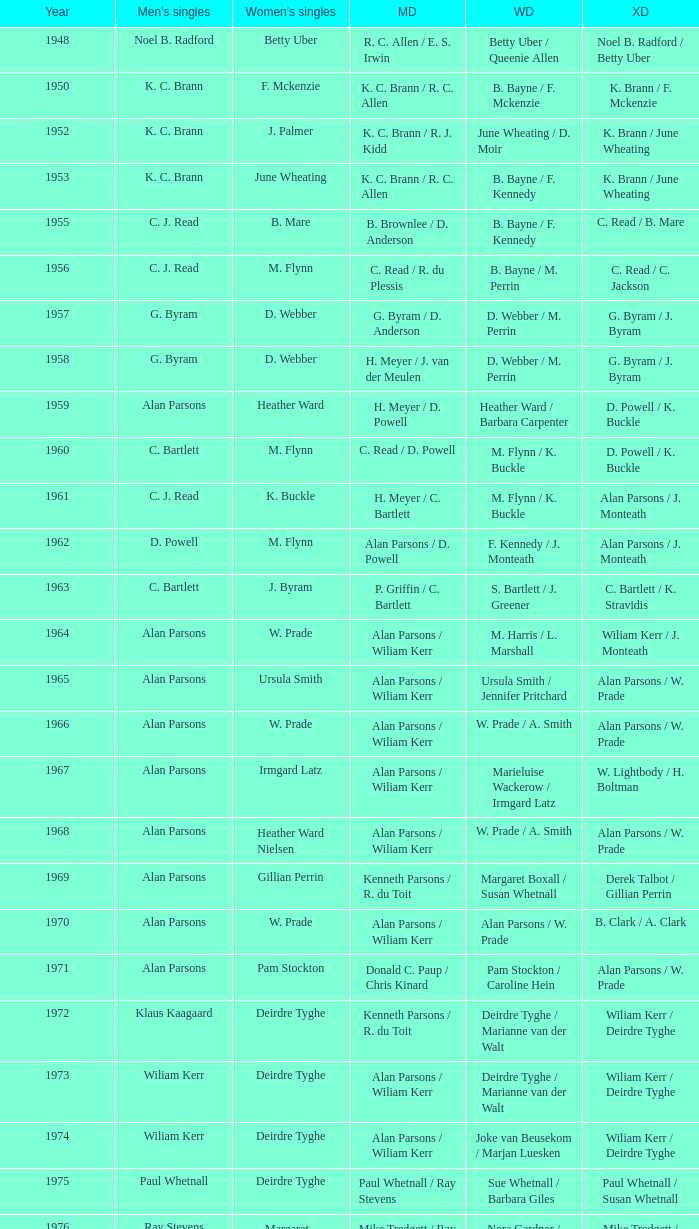Could you help me parse every detail presented in this table? {'header': ['Year', "Men's singles", "Women's singles", 'MD', 'WD', 'XD'], 'rows': [['1948', 'Noel B. Radford', 'Betty Uber', 'R. C. Allen / E. S. Irwin', 'Betty Uber / Queenie Allen', 'Noel B. Radford / Betty Uber'], ['1950', 'K. C. Brann', 'F. Mckenzie', 'K. C. Brann / R. C. Allen', 'B. Bayne / F. Mckenzie', 'K. Brann / F. Mckenzie'], ['1952', 'K. C. Brann', 'J. Palmer', 'K. C. Brann / R. J. Kidd', 'June Wheating / D. Moir', 'K. Brann / June Wheating'], ['1953', 'K. C. Brann', 'June Wheating', 'K. C. Brann / R. C. Allen', 'B. Bayne / F. Kennedy', 'K. Brann / June Wheating'], ['1955', 'C. J. Read', 'B. Mare', 'B. Brownlee / D. Anderson', 'B. Bayne / F. Kennedy', 'C. Read / B. Mare'], ['1956', 'C. J. Read', 'M. Flynn', 'C. Read / R. du Plessis', 'B. Bayne / M. Perrin', 'C. Read / C. Jackson'], ['1957', 'G. Byram', 'D. Webber', 'G. Byram / D. Anderson', 'D. Webber / M. Perrin', 'G. Byram / J. Byram'], ['1958', 'G. Byram', 'D. Webber', 'H. Meyer / J. van der Meulen', 'D. Webber / M. Perrin', 'G. Byram / J. Byram'], ['1959', 'Alan Parsons', 'Heather Ward', 'H. Meyer / D. Powell', 'Heather Ward / Barbara Carpenter', 'D. Powell / K. Buckle'], ['1960', 'C. Bartlett', 'M. Flynn', 'C. Read / D. Powell', 'M. Flynn / K. Buckle', 'D. Powell / K. Buckle'], ['1961', 'C. J. Read', 'K. Buckle', 'H. Meyer / C. Bartlett', 'M. Flynn / K. Buckle', 'Alan Parsons / J. Monteath'], ['1962', 'D. Powell', 'M. Flynn', 'Alan Parsons / D. Powell', 'F. Kennedy / J. Monteath', 'Alan Parsons / J. Monteath'], ['1963', 'C. Bartlett', 'J. Byram', 'P. Griffin / C. Bartlett', 'S. Bartlett / J. Greener', 'C. Bartlett / K. Stravidis'], ['1964', 'Alan Parsons', 'W. Prade', 'Alan Parsons / Wiliam Kerr', 'M. Harris / L. Marshall', 'Wiliam Kerr / J. Monteath'], ['1965', 'Alan Parsons', 'Ursula Smith', 'Alan Parsons / Wiliam Kerr', 'Ursula Smith / Jennifer Pritchard', 'Alan Parsons / W. Prade'], ['1966', 'Alan Parsons', 'W. Prade', 'Alan Parsons / Wiliam Kerr', 'W. Prade / A. Smith', 'Alan Parsons / W. Prade'], ['1967', 'Alan Parsons', 'Irmgard Latz', 'Alan Parsons / Wiliam Kerr', 'Marieluise Wackerow / Irmgard Latz', 'W. Lightbody / H. Boltman'], ['1968', 'Alan Parsons', 'Heather Ward Nielsen', 'Alan Parsons / Wiliam Kerr', 'W. Prade / A. Smith', 'Alan Parsons / W. Prade'], ['1969', 'Alan Parsons', 'Gillian Perrin', 'Kenneth Parsons / R. du Toit', 'Margaret Boxall / Susan Whetnall', 'Derek Talbot / Gillian Perrin'], ['1970', 'Alan Parsons', 'W. Prade', 'Alan Parsons / Wiliam Kerr', 'Alan Parsons / W. Prade', 'B. Clark / A. Clark'], ['1971', 'Alan Parsons', 'Pam Stockton', 'Donald C. Paup / Chris Kinard', 'Pam Stockton / Caroline Hein', 'Alan Parsons / W. Prade'], ['1972', 'Klaus Kaagaard', 'Deirdre Tyghe', 'Kenneth Parsons / R. du Toit', 'Deirdre Tyghe / Marianne van der Walt', 'Wiliam Kerr / Deirdre Tyghe'], ['1973', 'Wiliam Kerr', 'Deirdre Tyghe', 'Alan Parsons / Wiliam Kerr', 'Deirdre Tyghe / Marianne van der Walt', 'Wiliam Kerr / Deirdre Tyghe'], ['1974', 'Wiliam Kerr', 'Deirdre Tyghe', 'Alan Parsons / Wiliam Kerr', 'Joke van Beusekom / Marjan Luesken', 'Wiliam Kerr / Deirdre Tyghe'], ['1975', 'Paul Whetnall', 'Deirdre Tyghe', 'Paul Whetnall / Ray Stevens', 'Sue Whetnall / Barbara Giles', 'Paul Whetnall / Susan Whetnall'], ['1976', 'Ray Stevens', 'Margaret Lockwood', 'Mike Tredgett / Ray Stevens', 'Nora Gardner / Margaret Lockwood', 'Mike Tredgett / Nora Gardner'], ['1977', 'Wiliam Kerr', 'Deirdre Algie', 'Kenneth Parsons / Wiliam Kerr', 'Gussie Botes / Marianne van der Walt', 'Kenneth Parsons / Deirdre Algie'], ['1978', 'Gordon McMillan', 'Deirdre Algie', 'Gordon McMillan / John Abrahams', 'Gussie Botes / Marianne Abrahams', 'Kenneth Parsons / Deirdre Algie'], ['1979', 'Johan Croukamp', 'Gussie Botes', 'Gordon McMillan / John Abrahams', 'Gussie Botes / Marianne Abrahams', 'Alan Phillips / Gussie Botes'], ['1980', 'Chris Kinard', 'Utami Kinard', 'Alan Phillips / Kenneth Parsons', 'Gussie Phillips / Marianne Abrahams', 'Alan Phillips / Gussie Phillips'], ['1981', 'Johan Bosman', 'Deirdre Algie', 'Alan Phillips / Kenneth Parsons', 'Deirdre Algie / Karen Glenister', 'Alan Phillips / Gussie Phillips'], ['1982', 'Alan Phillips', 'Gussie Phillips', 'Alan Phillips / Kenneth Parsons', 'Gussie Phillips / Tracey Phillips', 'Alan Phillips / Gussie Phillips'], ['1983', 'Johan Croukamp', 'Gussie Phillips', 'Alan Phillips / David Phillips', 'Gussie Phillips / Tracey Phillips', 'Alan Phillips / Gussie Phillips'], ['1984', 'Johan Croukamp', 'Karen Glenister', 'Alan Phillips / David Phillips', 'Gussie Phillips / Tracey Phillips', 'Alan Phillips / Gussie Phillips'], ['1985', 'Johan Bosman', 'Gussie Phillips', 'Alan Phillips / David Phillips', 'Deirdre Algie / L. Humphrey', 'Alan Phillips / Gussie Phillips'], ['1986', 'Johan Bosman', 'Vanessa van der Walt', 'Alan Phillips / David Phillips', 'Gussie Phillips / Tracey Thompson', 'Alan Phillips / Gussie Phillips'], ['1987', 'Johan Bosman', 'Gussie Phillips', 'Alan Phillips / David Phillips', 'Gussie Phillips / Tracey Thompson', 'Alan Phillips / Gussie Phillips'], ['1988', 'Alan Phillips', 'Gussie Phillips', 'Alan Phillips / David Phillips', 'Gussie Phillips / Tracey Thompson', 'Alan Phillips / Gussie Phillips'], ['1989', 'Alan Phillips', 'Lina Fourie', 'Kenneth Parsons / Nico Meerholz', 'Gussie Phillips / Tracey Thompson', 'Alan Phillips / Gussie Phillips'], ['1990', 'Alan Phillips', 'Lina Fourie', 'Anton Kriel / Nico Meerholz', 'Gussie Phillips / Tracey Thompson', 'Alan Phillips / Gussie Phillips'], ['1991', 'Anton Kriel', 'Lina Fourie', 'Anton Kriel / Nico Meerholz', 'Lina Fourie / E. Fourie', 'Anton Kriel / Vanessa van der Walt'], ['1992', 'D. Plasson', 'Lina Fourie', 'Anton Kriel / Nico Meerholz', 'Gussie Phillips / Tracey Thompson', 'Anton Kriel / Vanessa van der Walt'], ['1993', 'Johan Kleingeld', 'Lina Fourie', 'Anton Kriel / Nico Meerholz', 'Gussie Phillips / Tracey Thompson', 'Johan Kleingeld / Lina Fourie'], ['1994', 'Johan Kleingeld', 'Lina Fourie', 'Anton Kriel / Nico Meerholz', 'Lina Fourie / Beverley Meerholz', 'Johan Kleingeld / Lina Fourie'], ['1995', 'Johan Kleingeld', 'Lina Fourie', 'Johan Kleingeld / Gavin Polmans', 'L. Humphrey / Monique Till', 'Alan Phillips / Gussie Phillips'], ['1996', 'Warren Parsons', 'Lina Fourie', 'Johan Kleingeld / Gavin Polmans', 'Linda Montignies / Monique Till', 'Anton Kriel / Vanessa van der Walt'], ['1997', 'Johan Kleingeld', 'Lina Fourie', 'Warren Parsons / Neale Woodroffe', 'Lina Fourie / Tracey Thompson', 'Johan Kleingeld / Lina Fourie'], ['1998', 'Johan Kleingeld', 'Lina Fourie', 'Gavin Polmans / Neale Woodroffe', 'Linda Montignies / Monique Ric-Hansen', 'Anton Kriel / Michelle Edwards'], ['1999', 'Michael Adams', 'Lina Fourie', 'Johan Kleingeld / Anton Kriel', 'Linda Montignies / Monique Ric-Hansen', 'Johan Kleingeld / Karen Coetzer'], ['2000', 'Michael Adams', 'Michelle Edwards', 'Nico Meerholz / Anton Kriel', 'Lina Fourie / Karen Coetzer', 'Anton Kriel / Michelle Edwards'], ['2001', 'Stewart Carson', 'Michelle Edwards', 'Chris Dednam / Johan Kleingeld', 'Lina Fourie / Karen Coetzer', 'Chris Dednam / Antoinette Uys'], ['2002', 'Stewart Carson', 'Michelle Edwards', 'Chris Dednam / Johan Kleingeld', 'Michelle Edwards / Chantal Botts', 'Johan Kleingeld / Marika Daubern'], ['2003', 'Chris Dednam', 'Michelle Edwards', 'Chris Dednam / Johan Kleingeld', 'Michelle Edwards / Chantal Botts', 'Johan Kleingeld / Marika Daubern'], ['2004', 'Chris Dednam', 'Michelle Edwards', 'Chris Dednam / Roelof Dednam', 'Michelle Edwards / Chantal Botts', 'Dorian James / Michelle Edwards'], ['2005', 'Chris Dednam', 'Marika Daubern', 'Chris Dednam / Roelof Dednam', 'Marika Daubern / Kerry Lee Harrington', 'Johan Kleingeld / Marika Daubern'], ['2006', 'Chris Dednam', 'Kerry Lee Harrington', 'Chris Dednam / Roelof Dednam', 'Michelle Edwards / Chantal Botts', 'Dorian James / Michelle Edwards'], ['2007', 'Wiaan Viljoen', 'Stacey Doubell', 'Chris Dednam / Roelof Dednam', 'Michelle Edwards / Chantal Botts', 'Dorian James / Michelle Edwards'], ['2008', 'Chris Dednam', 'Stacey Doubell', 'Chris Dednam / Roelof Dednam', 'Michelle Edwards / Chantal Botts', 'Chris Dednam / Michelle Edwards'], ['2009', 'Roelof Dednam', 'Kerry Lee Harrington', 'Dorian James / Wiaan Viljoen', 'Michelle Edwards / Annari Viljoen', 'Chris Dednam / Annari Viljoen']]} Which Men's doubles have a Year smaller than 1960, and Men's singles of noel b. radford? R. C. Allen / E. S. Irwin. 